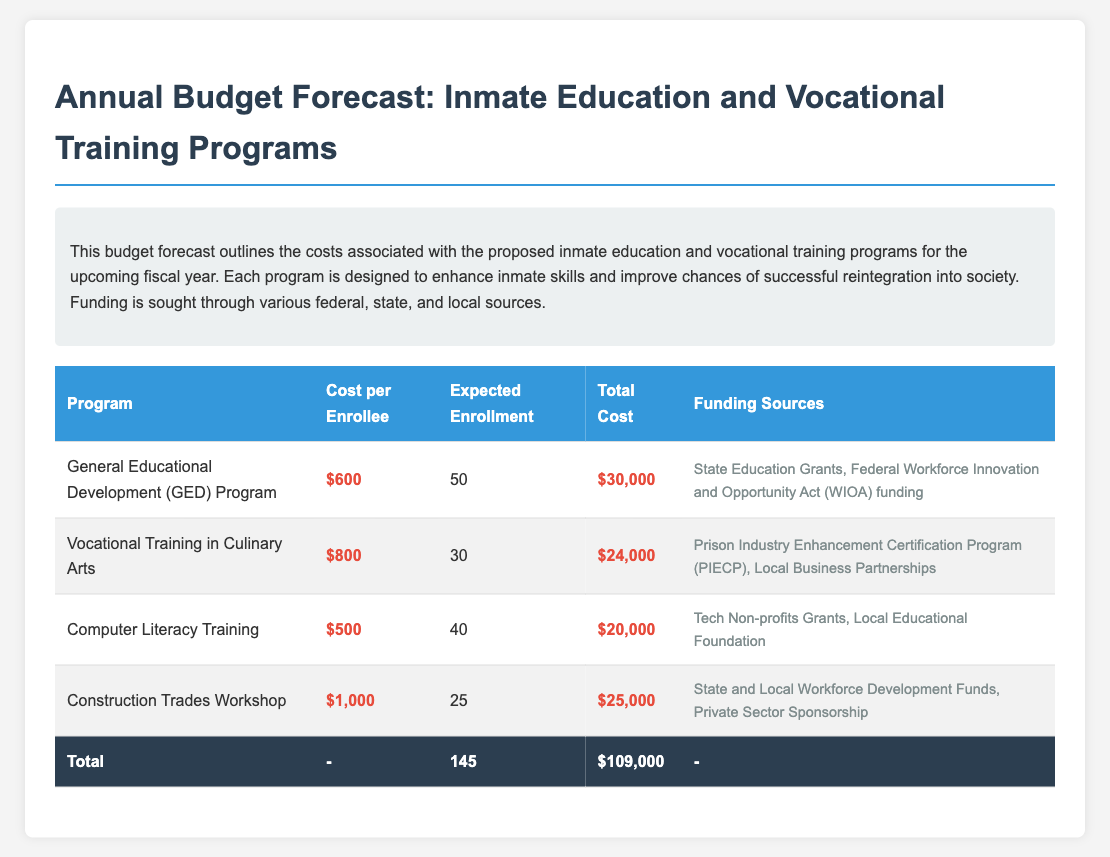What is the total cost for the GED Program? The total cost for the GED Program is listed as $30,000 in the document.
Answer: $30,000 How many expected enrollees are in the Computer Literacy Training? The number of expected enrollees in the Computer Literacy Training is provided as 40 in the document.
Answer: 40 What is the cost per enrollee for the Vocational Training in Culinary Arts? The document states the cost per enrollee for the Vocational Training in Culinary Arts is $800.
Answer: $800 What is the total expected enrollment across all programs? The total expected enrollment is the sum of all enrollees (50 + 30 + 40 + 25), which amounts to 145.
Answer: 145 Which funding source is associated with the Computer Literacy Training? The funding sources for the Computer Literacy Training include Tech Non-profits Grants and Local Educational Foundation as mentioned in the document.
Answer: Tech Non-profits Grants, Local Educational Foundation What is the most expensive training program listed? The document indicates that the Construction Trades Workshop is the most expensive program at $1,000 per enrollee.
Answer: Construction Trades Workshop How much is the total budget forecast for all programs combined? The document calculates the total budget forecast for all programs to be $109,000.
Answer: $109,000 What are the two main funding sources for the GED Program? The funding sources for the GED Program are identified as State Education Grants and Federal Workforce Innovation and Opportunity Act (WIOA) funding in the document.
Answer: State Education Grants, Federal Workforce Innovation and Opportunity Act (WIOA) funding 